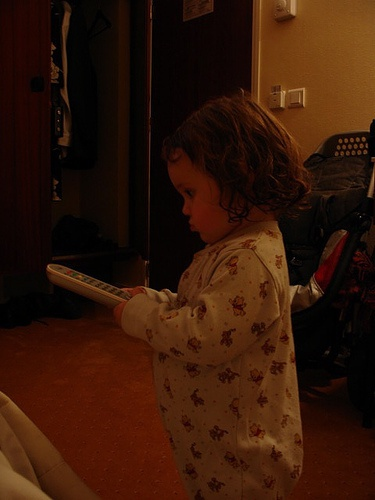Describe the objects in this image and their specific colors. I can see people in black, maroon, and olive tones and remote in black, maroon, and brown tones in this image. 